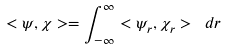<formula> <loc_0><loc_0><loc_500><loc_500>< \psi , \chi > = \int _ { - \infty } ^ { \infty } < \psi _ { r } , \chi _ { r } > \ d r</formula> 